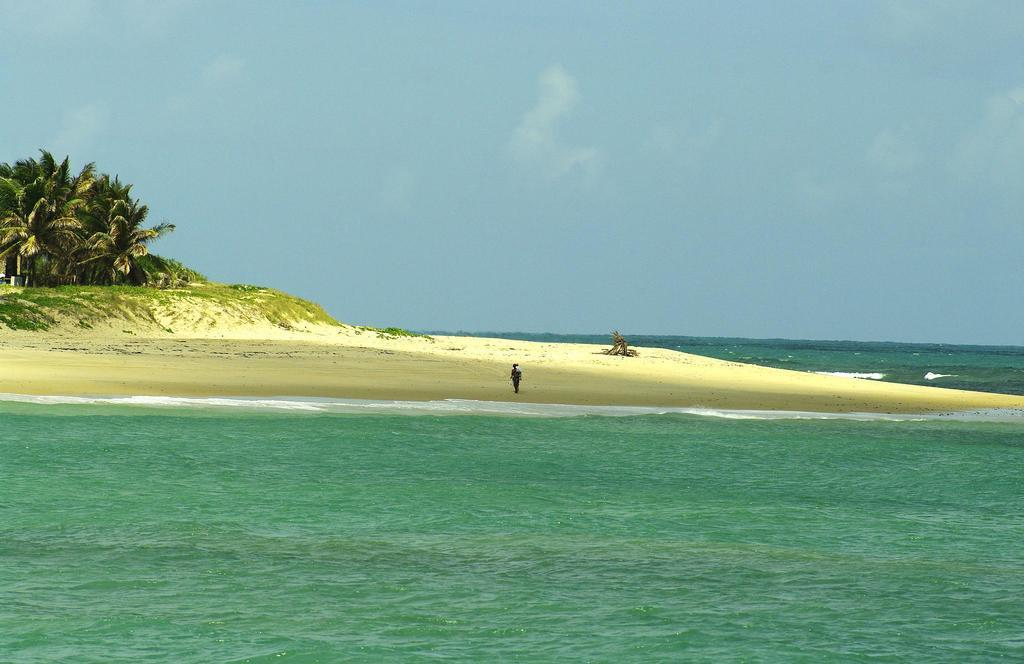What type of natural environment is depicted in the image? The image contains water, sand, grass, and trees, which suggests a natural environment such as a beach or park. What is the person in the image doing? The presence of water, sand, and grass suggests that the person might be enjoying outdoor activities or relaxing in the natural environment. What can be seen in the background of the image? The sky is visible in the background of the image. What type of window can be seen in the image? There is no window present in the image; it features a natural environment with water, sand, grass, trees, and a person. 